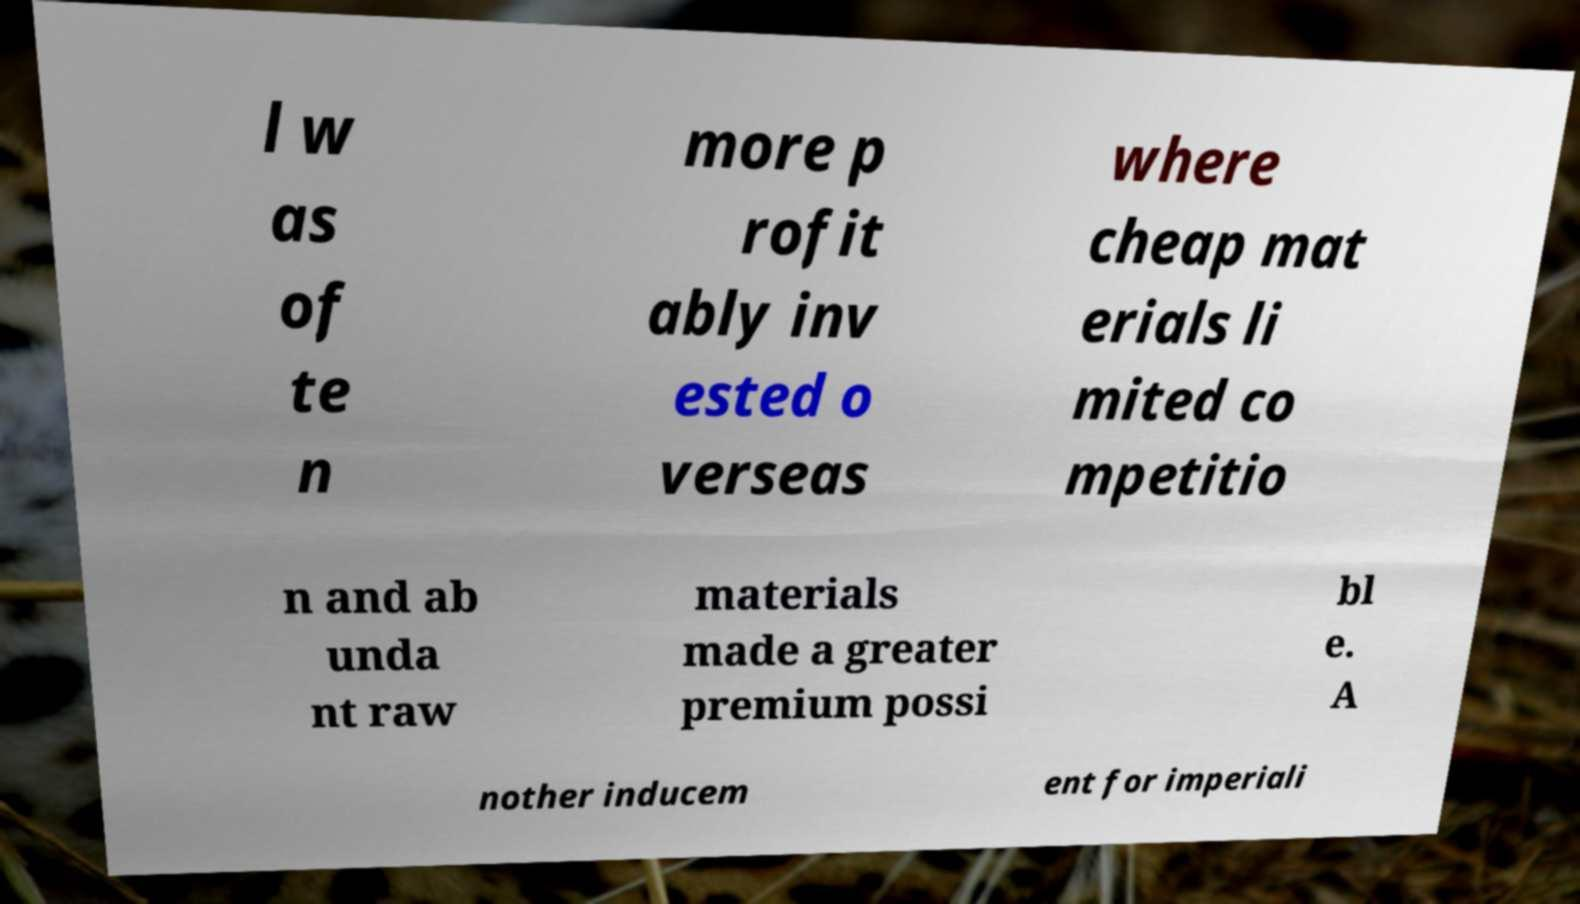Can you read and provide the text displayed in the image?This photo seems to have some interesting text. Can you extract and type it out for me? l w as of te n more p rofit ably inv ested o verseas where cheap mat erials li mited co mpetitio n and ab unda nt raw materials made a greater premium possi bl e. A nother inducem ent for imperiali 